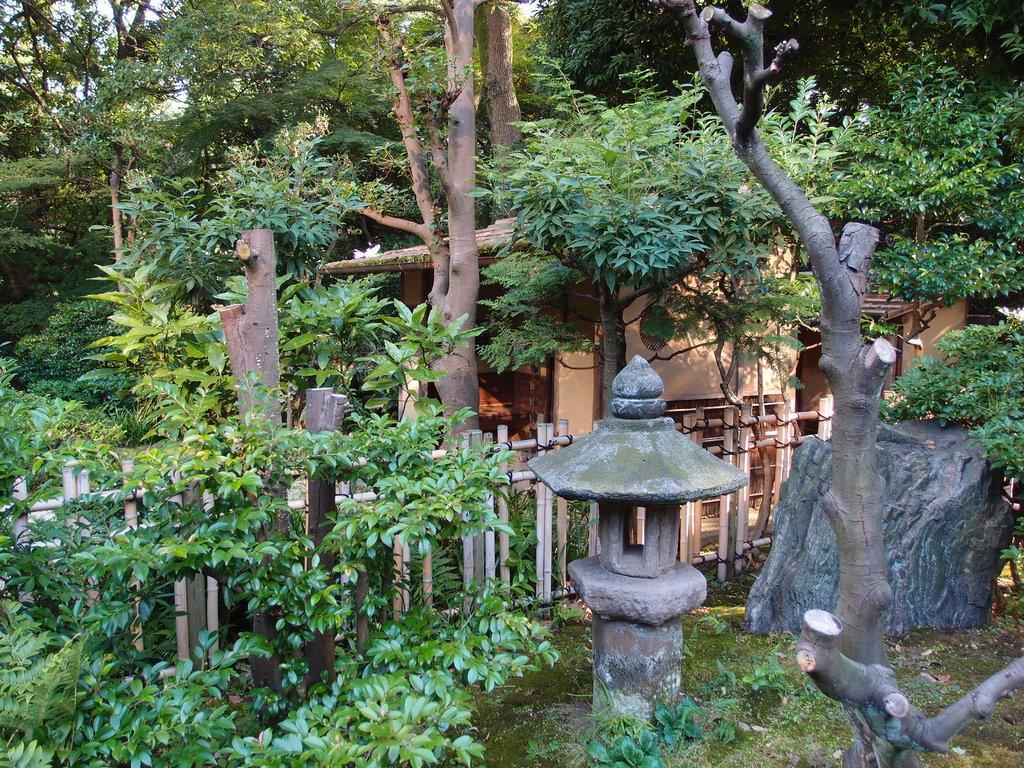Could you give a brief overview of what you see in this image? In this image it looks like it is a garden. In the background there are so many trees. On the right side there is a small house in the background. Beside the house there is a wooden fence. At the bottom there is a small cement pole in the middle. Beside it there is a stone. On the right side there is a tree trunk. On the left side there are small plants. 